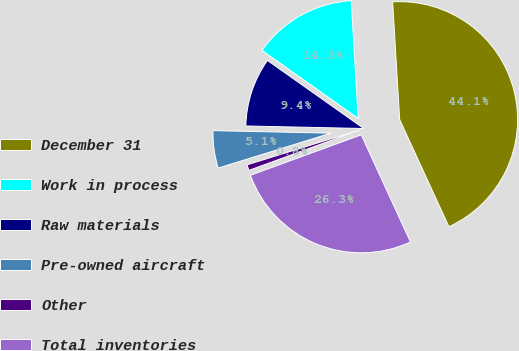Convert chart. <chart><loc_0><loc_0><loc_500><loc_500><pie_chart><fcel>December 31<fcel>Work in process<fcel>Raw materials<fcel>Pre-owned aircraft<fcel>Other<fcel>Total inventories<nl><fcel>44.09%<fcel>14.26%<fcel>9.45%<fcel>5.12%<fcel>0.79%<fcel>26.29%<nl></chart> 